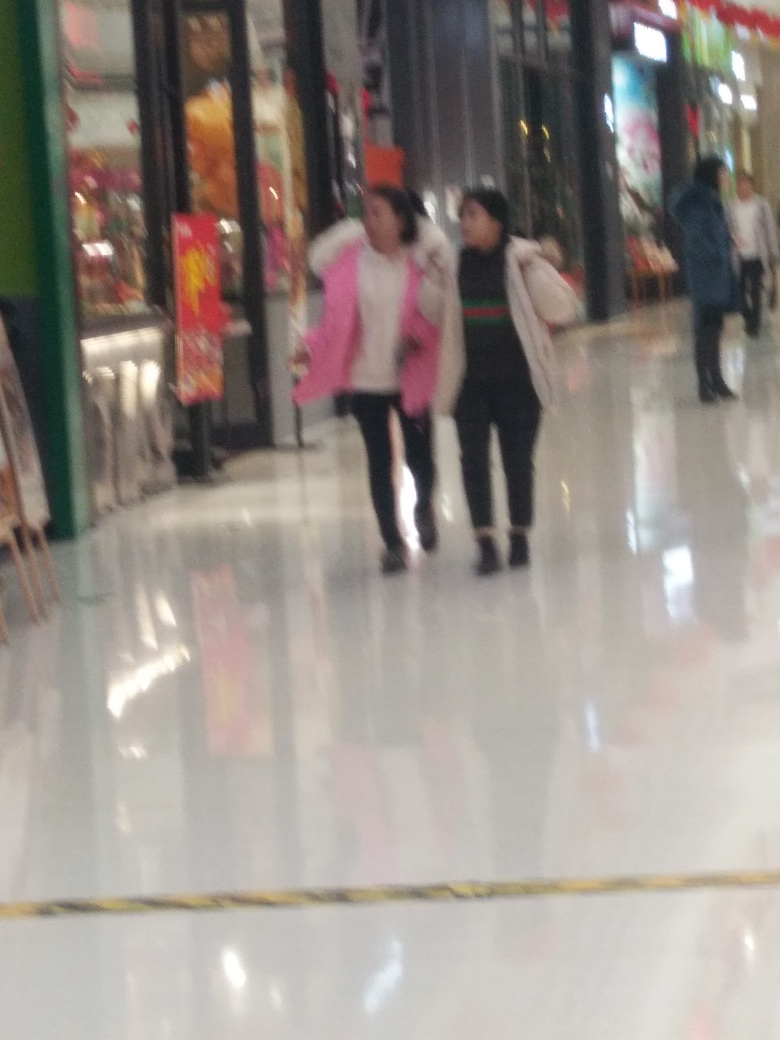Can you guess what time of year this photo may have been taken? Based on the clothing of the individuals, which includes jackets and long pants, it may suggest the photo was taken during a cooler season, potentially autumn or winter. The absence of holiday decorations suggests it may not be closely related to any major holidays during these seasons. 